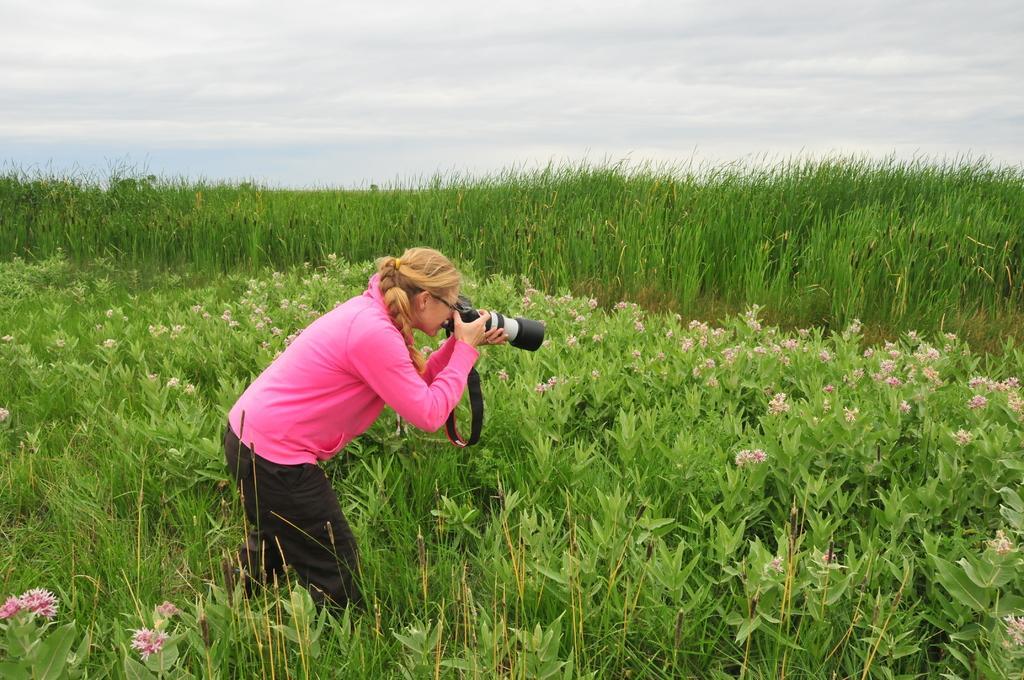Please provide a concise description of this image. In the middle of the image a person is standing and holding a camera. Behind her there are some plants and grass. At the top of the image there are some clouds and sky. 